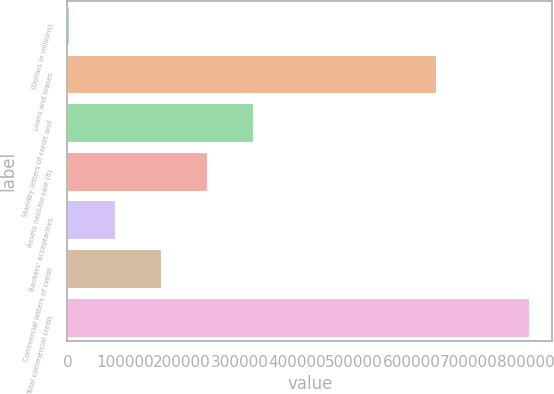Convert chart to OTSL. <chart><loc_0><loc_0><loc_500><loc_500><bar_chart><fcel>(Dollars in millions)<fcel>Loans and leases<fcel>Standby letters of credit and<fcel>Assets held-for-sale (6)<fcel>Bankers' acceptances<fcel>Commercial letters of credit<fcel>Total commercial credit<nl><fcel>2008<fcel>643623<fcel>323338<fcel>243005<fcel>82340.4<fcel>162673<fcel>805332<nl></chart> 